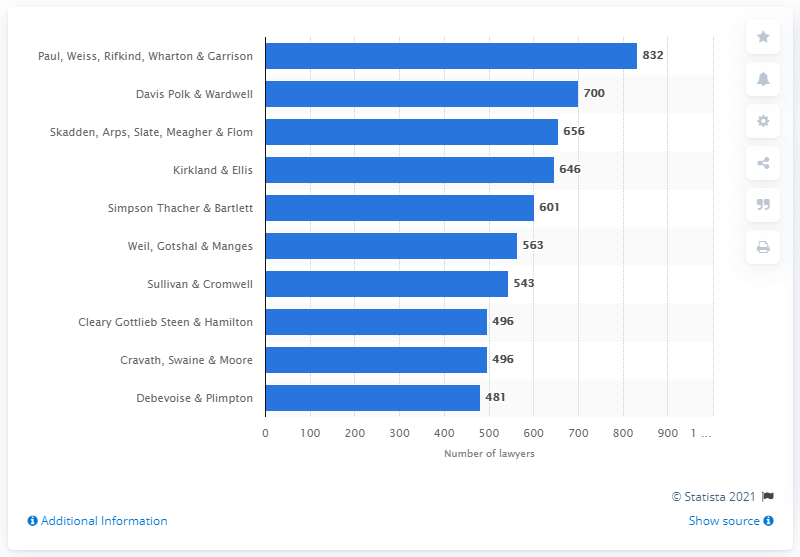Specify some key components in this picture. Paul, Weiss, Rifkind, Wharton & Garrison employed 832 lawyers. 